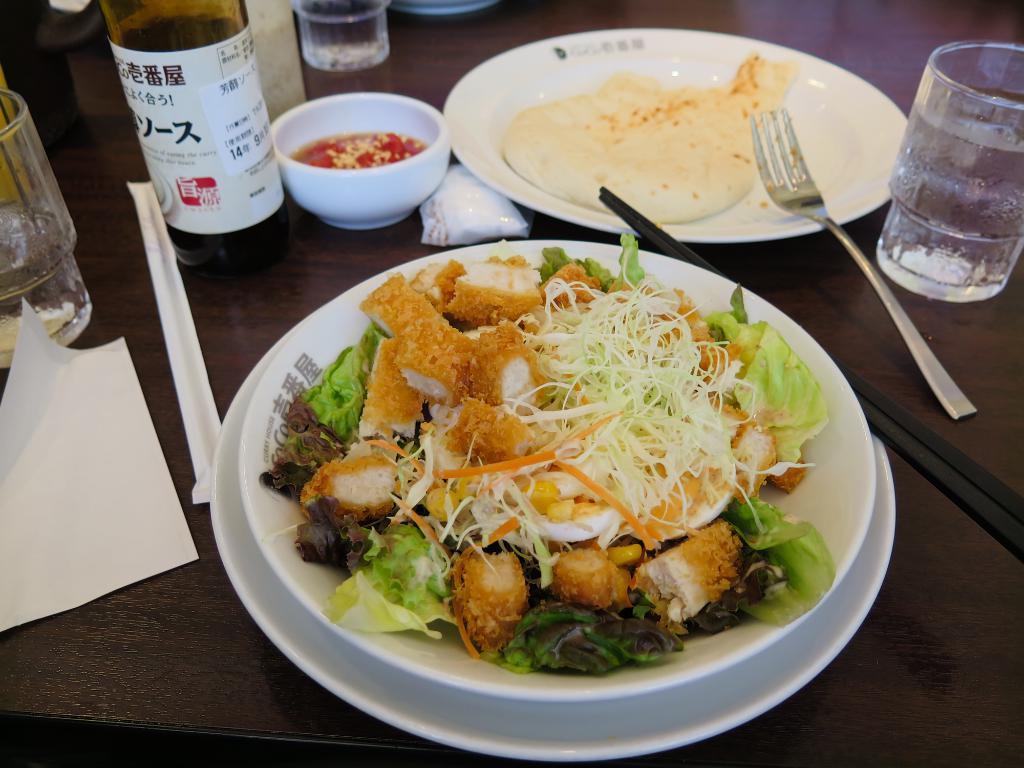How would you summarize this image in a sentence or two? In the foreground of this picture we can see a table on the top of which glasses, bottle, bowl containing some food item and a fork, platters containing food items and some other objects are placed. On the left we can see the text and numbers on the paper which is attached to the bottle. 